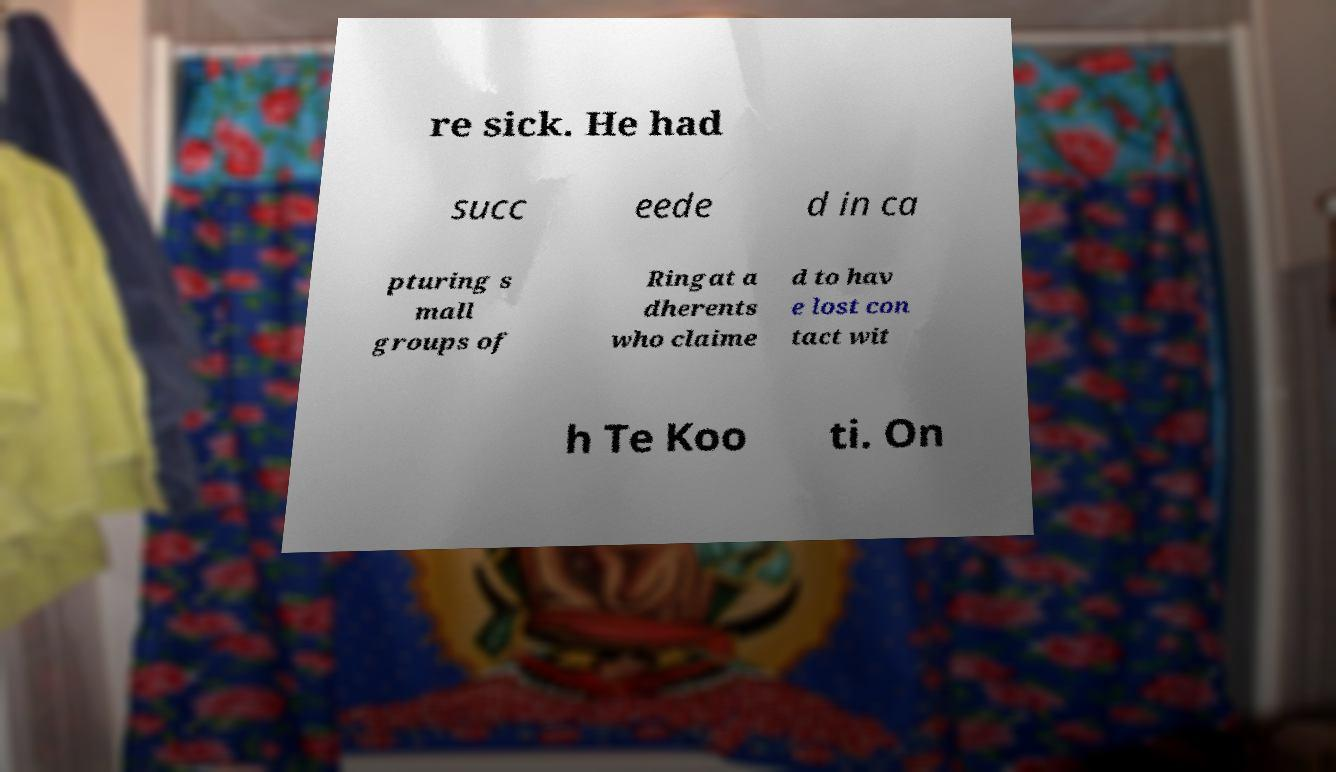Please read and relay the text visible in this image. What does it say? re sick. He had succ eede d in ca pturing s mall groups of Ringat a dherents who claime d to hav e lost con tact wit h Te Koo ti. On 